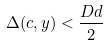Convert formula to latex. <formula><loc_0><loc_0><loc_500><loc_500>\Delta ( c , y ) < \frac { D d } { 2 }</formula> 